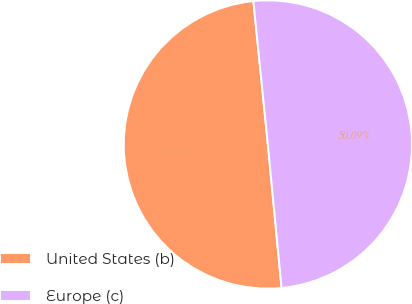Convert chart. <chart><loc_0><loc_0><loc_500><loc_500><pie_chart><fcel>United States (b)<fcel>Europe (c)<nl><fcel>49.91%<fcel>50.09%<nl></chart> 